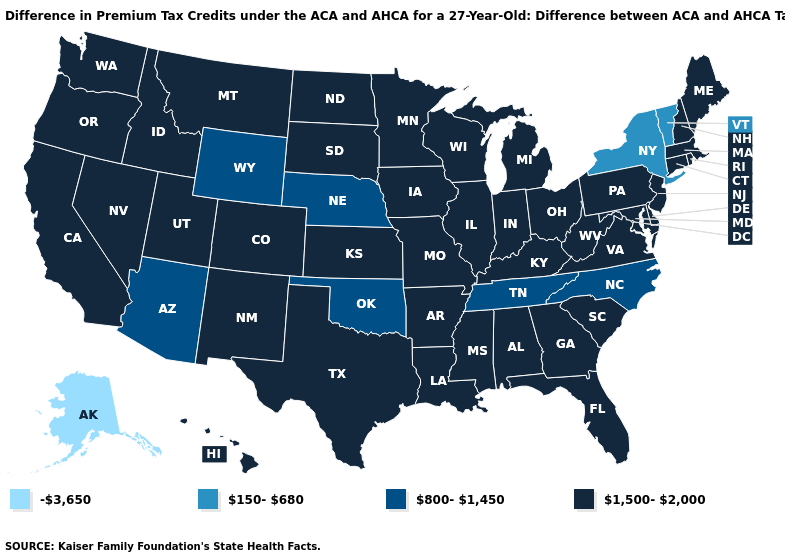Which states have the lowest value in the USA?
Give a very brief answer. Alaska. Does Hawaii have the same value as Wyoming?
Give a very brief answer. No. What is the highest value in the USA?
Quick response, please. 1,500-2,000. Name the states that have a value in the range -3,650?
Answer briefly. Alaska. Does North Dakota have the same value as New York?
Quick response, please. No. How many symbols are there in the legend?
Concise answer only. 4. How many symbols are there in the legend?
Concise answer only. 4. Which states have the lowest value in the USA?
Answer briefly. Alaska. Name the states that have a value in the range 150-680?
Answer briefly. New York, Vermont. What is the value of New Mexico?
Write a very short answer. 1,500-2,000. What is the value of Arkansas?
Keep it brief. 1,500-2,000. Name the states that have a value in the range 150-680?
Concise answer only. New York, Vermont. What is the value of Oklahoma?
Quick response, please. 800-1,450. What is the value of Virginia?
Give a very brief answer. 1,500-2,000. Name the states that have a value in the range 800-1,450?
Quick response, please. Arizona, Nebraska, North Carolina, Oklahoma, Tennessee, Wyoming. 